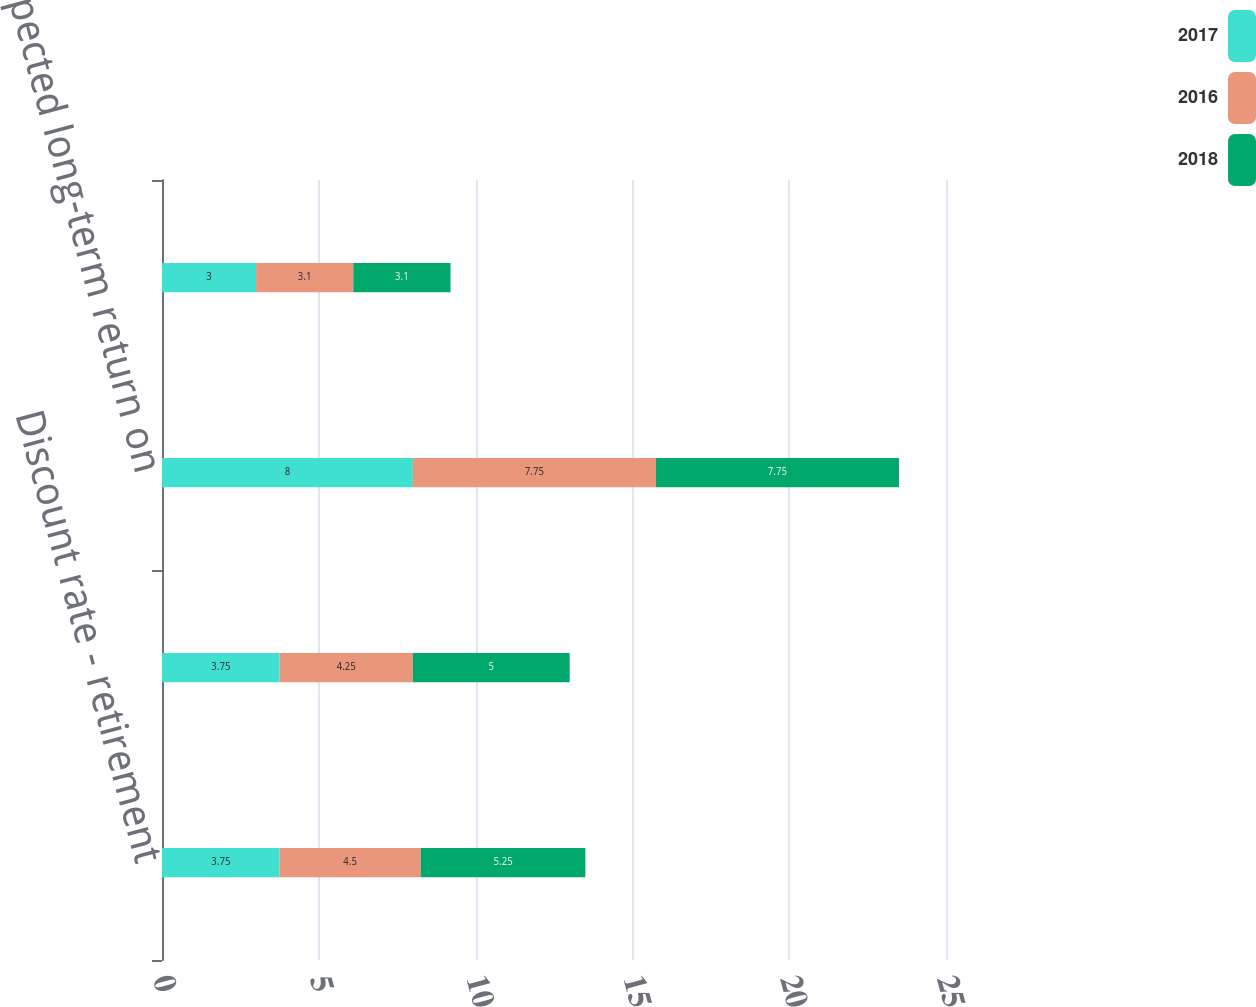Convert chart. <chart><loc_0><loc_0><loc_500><loc_500><stacked_bar_chart><ecel><fcel>Discount rate - retirement<fcel>Discount rate - other<fcel>Expected long-term return on<fcel>Compensation increase rate<nl><fcel>2017<fcel>3.75<fcel>3.75<fcel>8<fcel>3<nl><fcel>2016<fcel>4.5<fcel>4.25<fcel>7.75<fcel>3.1<nl><fcel>2018<fcel>5.25<fcel>5<fcel>7.75<fcel>3.1<nl></chart> 